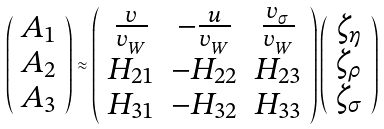<formula> <loc_0><loc_0><loc_500><loc_500>\left ( \begin{array} { c } { { A _ { 1 } } } \\ { { A _ { 2 } } } \\ { { A _ { 3 } } } \end{array} \right ) \approx \left ( \begin{array} { c c c } { { \frac { v } { v _ { _ { W } } } } } & { { - \frac { u } { v _ { _ { W } } } } } & { { \frac { v _ { _ { \sigma } } } { v _ { _ { W } } } } } \\ { { H _ { 2 1 } } } & { { - H _ { 2 2 } } } & { { H _ { 2 3 } } } \\ { { H _ { 3 1 } } } & { { - H _ { 3 2 } } } & { { H _ { 3 3 } } } \end{array} \right ) \left ( \begin{array} { c } { { \zeta _ { \eta } } } \\ { { \zeta _ { \rho } } } \\ { { \zeta _ { \sigma } } } \end{array} \right )</formula> 